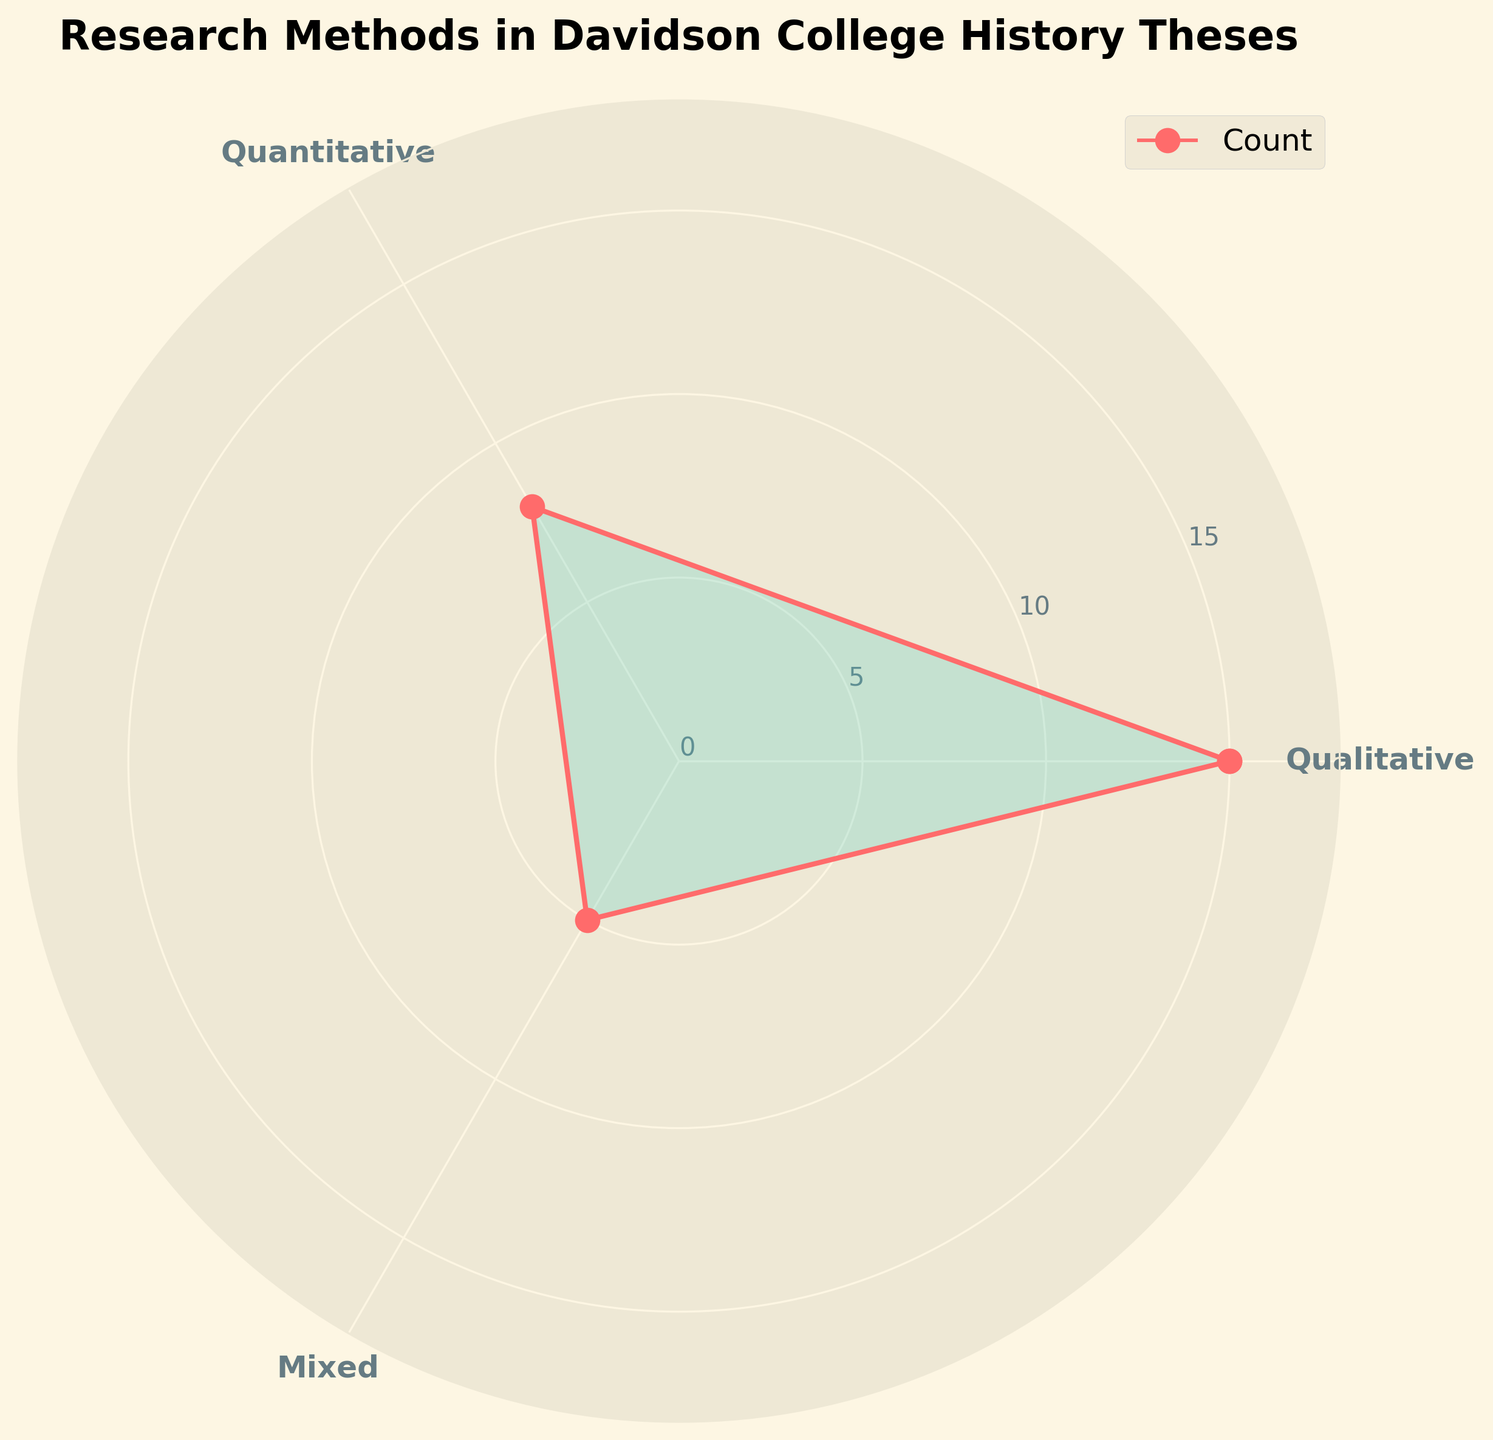What is the title of the figure? The title of the figure is usually located at the top of the chart. In this figure, it is clearly written at the top and states "Research Methods in Davidson College History Theses."
Answer: Research Methods in Davidson College History Theses Which research method was used the most by Davidson College history students? To find the most used research method, look at the data points on the rose chart that reaches the furthest from the center. In this case, the "Qualitative" method peaks the highest.
Answer: Qualitative How many counts are there for the "Mixed" research method? Identify the segment associated with the "Mixed" research method. The visual information shows the segment for "Mixed" is marked at 5 counts.
Answer: 5 Compare the counts between "Qualitative" and "Quantitative" research methods. Which one is higher? By comparing the lengths of the two sections on the rose chart, we observe that the count for "Qualitative" is 15, which is higher than "Quantitative," which has a count of 8.
Answer: Qualitative What is the combined total of counts for all research methods? Add up the counts from each segment on the rose chart: 15 (Qualitative) + 8 (Quantitative) + 5 (Mixed) = 28.
Answer: 28 How many more times was the "Qualitative" method used compared to the "Mixed" method? Calculate the difference between "Qualitative" (15) and "Mixed" (5) counts and then divide by the "Mixed" count: (15 - 5) / 5 = 2.
Answer: 2 times more What color represents the count points on the rose chart? The count points are shown through the markers at different angles on the rose chart. These markers are colored red.
Answer: Red If you average the counts of all three research methods, what value do you get? First, sum the counts: 15 (Qualitative) + 8 (Quantitative) + 5 (Mixed) = 28. Then divide by the number of methods: 28 / 3 ~= 9.33.
Answer: 9.33 Identify the research method that is represented by the color cyan in the filled area of the rose chart. In the rose chart, the color cyan fills the areas under the plot lines for every segment. It does not correspond exclusively to one method but envelops all methods.
Answer: All methods What proportion of history theses used quantitative methods compared to the total? Divide the count for "Quantitative" by the total count: 8 / 28, then convert to a percentage by multiplying by 100: (8/28) * 100 ~= 28.57%.
Answer: 28.57% 